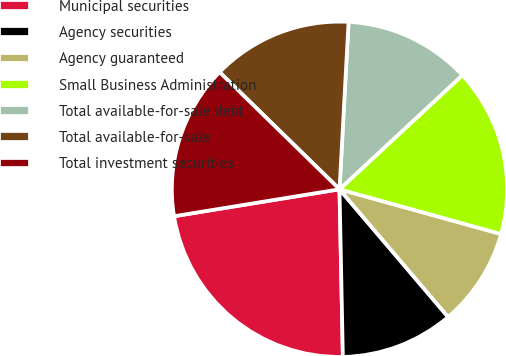Convert chart to OTSL. <chart><loc_0><loc_0><loc_500><loc_500><pie_chart><fcel>Municipal securities<fcel>Agency securities<fcel>Agency guaranteed<fcel>Small Business Administration<fcel>Total available-for-sale debt<fcel>Total available-for-sale<fcel>Total investment securities<nl><fcel>22.75%<fcel>10.9%<fcel>9.48%<fcel>16.21%<fcel>12.23%<fcel>13.55%<fcel>14.88%<nl></chart> 